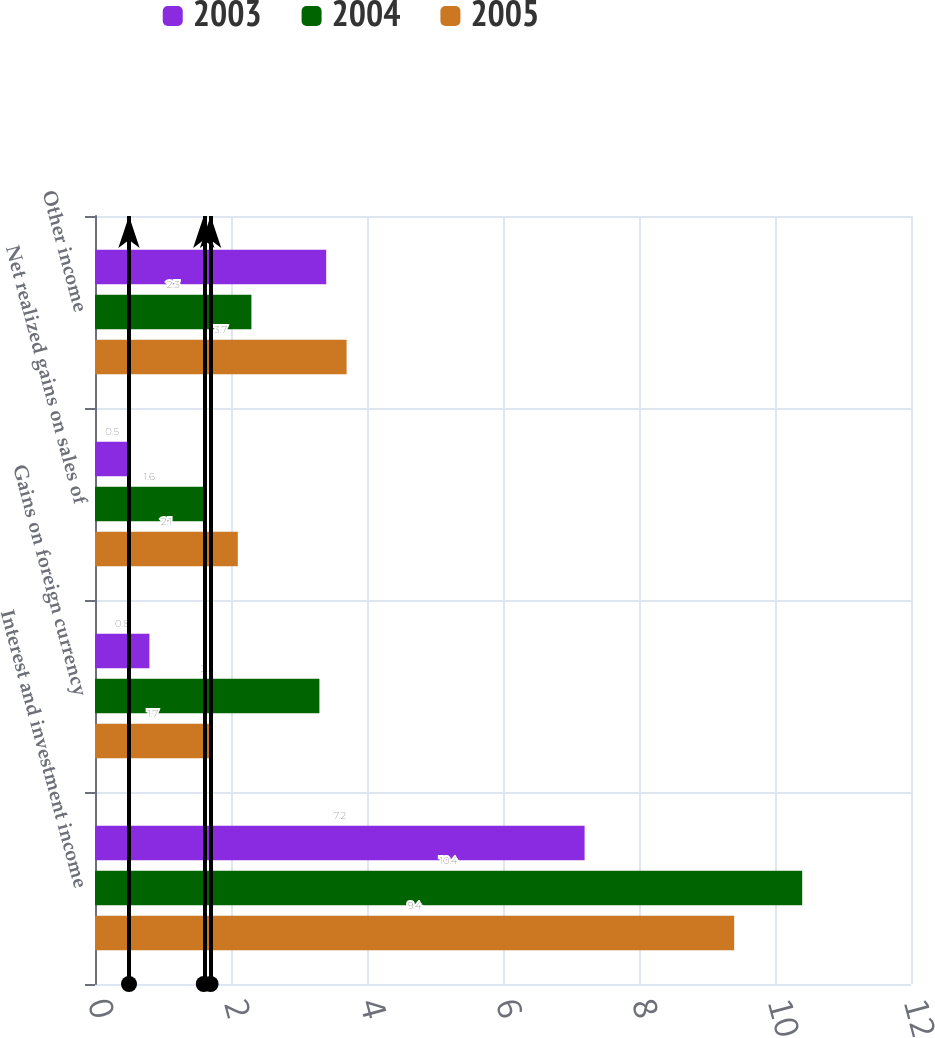Convert chart. <chart><loc_0><loc_0><loc_500><loc_500><stacked_bar_chart><ecel><fcel>Interest and investment income<fcel>Gains on foreign currency<fcel>Net realized gains on sales of<fcel>Other income<nl><fcel>2003<fcel>7.2<fcel>0.8<fcel>0.5<fcel>3.4<nl><fcel>2004<fcel>10.4<fcel>3.3<fcel>1.6<fcel>2.3<nl><fcel>2005<fcel>9.4<fcel>1.7<fcel>2.1<fcel>3.7<nl></chart> 